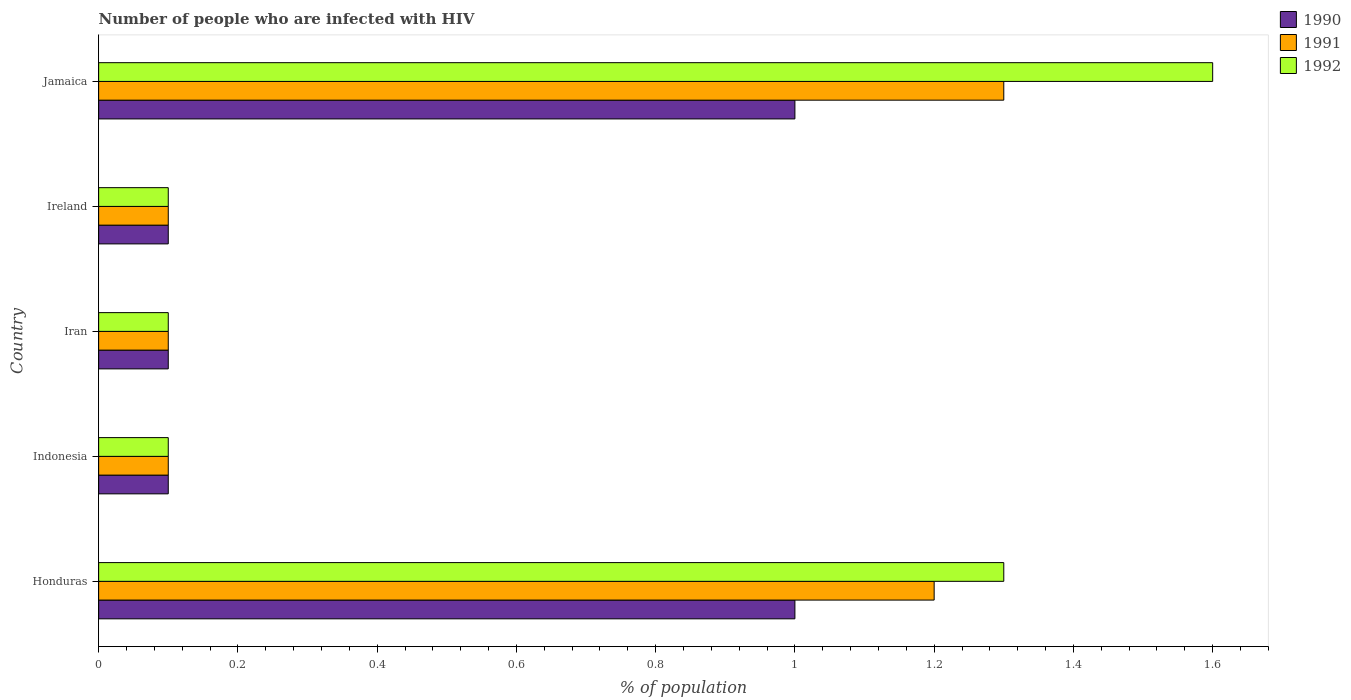How many different coloured bars are there?
Your response must be concise. 3. How many groups of bars are there?
Your answer should be compact. 5. What is the label of the 1st group of bars from the top?
Offer a terse response. Jamaica. In how many cases, is the number of bars for a given country not equal to the number of legend labels?
Give a very brief answer. 0. What is the percentage of HIV infected population in in 1991 in Jamaica?
Make the answer very short. 1.3. In which country was the percentage of HIV infected population in in 1990 maximum?
Ensure brevity in your answer.  Honduras. In which country was the percentage of HIV infected population in in 1992 minimum?
Your answer should be compact. Indonesia. What is the total percentage of HIV infected population in in 1991 in the graph?
Offer a very short reply. 2.8. What is the difference between the percentage of HIV infected population in in 1991 in Honduras and that in Ireland?
Make the answer very short. 1.1. What is the difference between the percentage of HIV infected population in in 1991 in Honduras and the percentage of HIV infected population in in 1990 in Ireland?
Ensure brevity in your answer.  1.1. What is the average percentage of HIV infected population in in 1992 per country?
Your response must be concise. 0.64. What is the difference between the percentage of HIV infected population in in 1991 and percentage of HIV infected population in in 1990 in Honduras?
Ensure brevity in your answer.  0.2. In how many countries, is the percentage of HIV infected population in in 1991 greater than 1.4000000000000001 %?
Your answer should be compact. 0. Is the percentage of HIV infected population in in 1990 in Indonesia less than that in Jamaica?
Give a very brief answer. Yes. Is the difference between the percentage of HIV infected population in in 1991 in Honduras and Indonesia greater than the difference between the percentage of HIV infected population in in 1990 in Honduras and Indonesia?
Your response must be concise. Yes. What is the difference between the highest and the second highest percentage of HIV infected population in in 1992?
Give a very brief answer. 0.3. In how many countries, is the percentage of HIV infected population in in 1991 greater than the average percentage of HIV infected population in in 1991 taken over all countries?
Provide a short and direct response. 2. Is the sum of the percentage of HIV infected population in in 1990 in Honduras and Ireland greater than the maximum percentage of HIV infected population in in 1992 across all countries?
Offer a very short reply. No. Is it the case that in every country, the sum of the percentage of HIV infected population in in 1992 and percentage of HIV infected population in in 1990 is greater than the percentage of HIV infected population in in 1991?
Give a very brief answer. Yes. Are all the bars in the graph horizontal?
Ensure brevity in your answer.  Yes. How many countries are there in the graph?
Offer a very short reply. 5. What is the difference between two consecutive major ticks on the X-axis?
Provide a succinct answer. 0.2. Does the graph contain any zero values?
Your answer should be compact. No. How many legend labels are there?
Offer a very short reply. 3. What is the title of the graph?
Make the answer very short. Number of people who are infected with HIV. What is the label or title of the X-axis?
Make the answer very short. % of population. What is the % of population of 1991 in Honduras?
Offer a very short reply. 1.2. What is the % of population in 1992 in Honduras?
Make the answer very short. 1.3. What is the % of population in 1991 in Indonesia?
Make the answer very short. 0.1. What is the % of population of 1990 in Iran?
Provide a short and direct response. 0.1. What is the % of population of 1991 in Iran?
Your answer should be very brief. 0.1. What is the % of population of 1991 in Ireland?
Offer a terse response. 0.1. What is the % of population in 1990 in Jamaica?
Your answer should be compact. 1. What is the % of population in 1991 in Jamaica?
Give a very brief answer. 1.3. Across all countries, what is the maximum % of population of 1991?
Your answer should be compact. 1.3. Across all countries, what is the minimum % of population in 1992?
Make the answer very short. 0.1. What is the difference between the % of population in 1990 in Honduras and that in Indonesia?
Offer a terse response. 0.9. What is the difference between the % of population in 1991 in Honduras and that in Indonesia?
Keep it short and to the point. 1.1. What is the difference between the % of population in 1992 in Honduras and that in Indonesia?
Your answer should be very brief. 1.2. What is the difference between the % of population in 1991 in Honduras and that in Iran?
Offer a terse response. 1.1. What is the difference between the % of population of 1992 in Honduras and that in Iran?
Give a very brief answer. 1.2. What is the difference between the % of population of 1990 in Honduras and that in Ireland?
Keep it short and to the point. 0.9. What is the difference between the % of population of 1991 in Honduras and that in Jamaica?
Offer a very short reply. -0.1. What is the difference between the % of population of 1991 in Indonesia and that in Iran?
Your response must be concise. 0. What is the difference between the % of population in 1991 in Indonesia and that in Ireland?
Your answer should be compact. 0. What is the difference between the % of population in 1992 in Indonesia and that in Ireland?
Ensure brevity in your answer.  0. What is the difference between the % of population in 1990 in Indonesia and that in Jamaica?
Provide a short and direct response. -0.9. What is the difference between the % of population of 1991 in Indonesia and that in Jamaica?
Offer a terse response. -1.2. What is the difference between the % of population of 1991 in Iran and that in Ireland?
Make the answer very short. 0. What is the difference between the % of population of 1992 in Iran and that in Ireland?
Provide a short and direct response. 0. What is the difference between the % of population in 1990 in Iran and that in Jamaica?
Provide a short and direct response. -0.9. What is the difference between the % of population of 1992 in Iran and that in Jamaica?
Keep it short and to the point. -1.5. What is the difference between the % of population of 1990 in Ireland and that in Jamaica?
Give a very brief answer. -0.9. What is the difference between the % of population of 1991 in Ireland and that in Jamaica?
Provide a succinct answer. -1.2. What is the difference between the % of population in 1990 in Honduras and the % of population in 1991 in Indonesia?
Keep it short and to the point. 0.9. What is the difference between the % of population in 1991 in Honduras and the % of population in 1992 in Indonesia?
Provide a succinct answer. 1.1. What is the difference between the % of population in 1990 in Honduras and the % of population in 1992 in Iran?
Give a very brief answer. 0.9. What is the difference between the % of population of 1991 in Honduras and the % of population of 1992 in Iran?
Your answer should be compact. 1.1. What is the difference between the % of population of 1990 in Honduras and the % of population of 1991 in Ireland?
Make the answer very short. 0.9. What is the difference between the % of population of 1990 in Honduras and the % of population of 1992 in Ireland?
Keep it short and to the point. 0.9. What is the difference between the % of population in 1991 in Honduras and the % of population in 1992 in Ireland?
Give a very brief answer. 1.1. What is the difference between the % of population of 1990 in Honduras and the % of population of 1991 in Jamaica?
Ensure brevity in your answer.  -0.3. What is the difference between the % of population of 1990 in Honduras and the % of population of 1992 in Jamaica?
Offer a very short reply. -0.6. What is the difference between the % of population in 1990 in Indonesia and the % of population in 1992 in Jamaica?
Keep it short and to the point. -1.5. What is the difference between the % of population in 1990 in Iran and the % of population in 1991 in Ireland?
Provide a succinct answer. 0. What is the difference between the % of population of 1990 in Iran and the % of population of 1992 in Jamaica?
Your answer should be compact. -1.5. What is the difference between the % of population in 1991 in Iran and the % of population in 1992 in Jamaica?
Ensure brevity in your answer.  -1.5. What is the difference between the % of population in 1990 in Ireland and the % of population in 1991 in Jamaica?
Your answer should be very brief. -1.2. What is the difference between the % of population in 1990 in Ireland and the % of population in 1992 in Jamaica?
Make the answer very short. -1.5. What is the difference between the % of population of 1991 in Ireland and the % of population of 1992 in Jamaica?
Ensure brevity in your answer.  -1.5. What is the average % of population in 1990 per country?
Ensure brevity in your answer.  0.46. What is the average % of population in 1991 per country?
Provide a succinct answer. 0.56. What is the average % of population of 1992 per country?
Offer a very short reply. 0.64. What is the difference between the % of population of 1990 and % of population of 1992 in Honduras?
Your answer should be compact. -0.3. What is the difference between the % of population in 1991 and % of population in 1992 in Honduras?
Give a very brief answer. -0.1. What is the difference between the % of population in 1990 and % of population in 1991 in Iran?
Make the answer very short. 0. What is the difference between the % of population in 1990 and % of population in 1992 in Iran?
Your answer should be very brief. 0. What is the difference between the % of population of 1990 and % of population of 1991 in Ireland?
Your answer should be very brief. 0. What is the difference between the % of population of 1991 and % of population of 1992 in Ireland?
Offer a terse response. 0. What is the difference between the % of population of 1990 and % of population of 1991 in Jamaica?
Offer a very short reply. -0.3. What is the difference between the % of population in 1990 and % of population in 1992 in Jamaica?
Keep it short and to the point. -0.6. What is the ratio of the % of population of 1992 in Honduras to that in Indonesia?
Offer a terse response. 13. What is the ratio of the % of population in 1990 in Honduras to that in Iran?
Ensure brevity in your answer.  10. What is the ratio of the % of population in 1991 in Honduras to that in Iran?
Your response must be concise. 12. What is the ratio of the % of population in 1992 in Honduras to that in Iran?
Your answer should be very brief. 13. What is the ratio of the % of population in 1990 in Honduras to that in Ireland?
Your response must be concise. 10. What is the ratio of the % of population of 1992 in Honduras to that in Jamaica?
Give a very brief answer. 0.81. What is the ratio of the % of population of 1990 in Indonesia to that in Ireland?
Offer a very short reply. 1. What is the ratio of the % of population in 1991 in Indonesia to that in Ireland?
Provide a short and direct response. 1. What is the ratio of the % of population of 1992 in Indonesia to that in Ireland?
Your answer should be compact. 1. What is the ratio of the % of population in 1990 in Indonesia to that in Jamaica?
Give a very brief answer. 0.1. What is the ratio of the % of population of 1991 in Indonesia to that in Jamaica?
Your answer should be compact. 0.08. What is the ratio of the % of population of 1992 in Indonesia to that in Jamaica?
Provide a succinct answer. 0.06. What is the ratio of the % of population in 1990 in Iran to that in Ireland?
Your answer should be very brief. 1. What is the ratio of the % of population of 1992 in Iran to that in Ireland?
Make the answer very short. 1. What is the ratio of the % of population in 1991 in Iran to that in Jamaica?
Keep it short and to the point. 0.08. What is the ratio of the % of population in 1992 in Iran to that in Jamaica?
Offer a very short reply. 0.06. What is the ratio of the % of population in 1991 in Ireland to that in Jamaica?
Offer a terse response. 0.08. What is the ratio of the % of population of 1992 in Ireland to that in Jamaica?
Make the answer very short. 0.06. What is the difference between the highest and the second highest % of population of 1990?
Offer a very short reply. 0. What is the difference between the highest and the second highest % of population in 1991?
Your answer should be very brief. 0.1. What is the difference between the highest and the lowest % of population of 1990?
Give a very brief answer. 0.9. What is the difference between the highest and the lowest % of population in 1991?
Your answer should be compact. 1.2. What is the difference between the highest and the lowest % of population of 1992?
Your answer should be very brief. 1.5. 